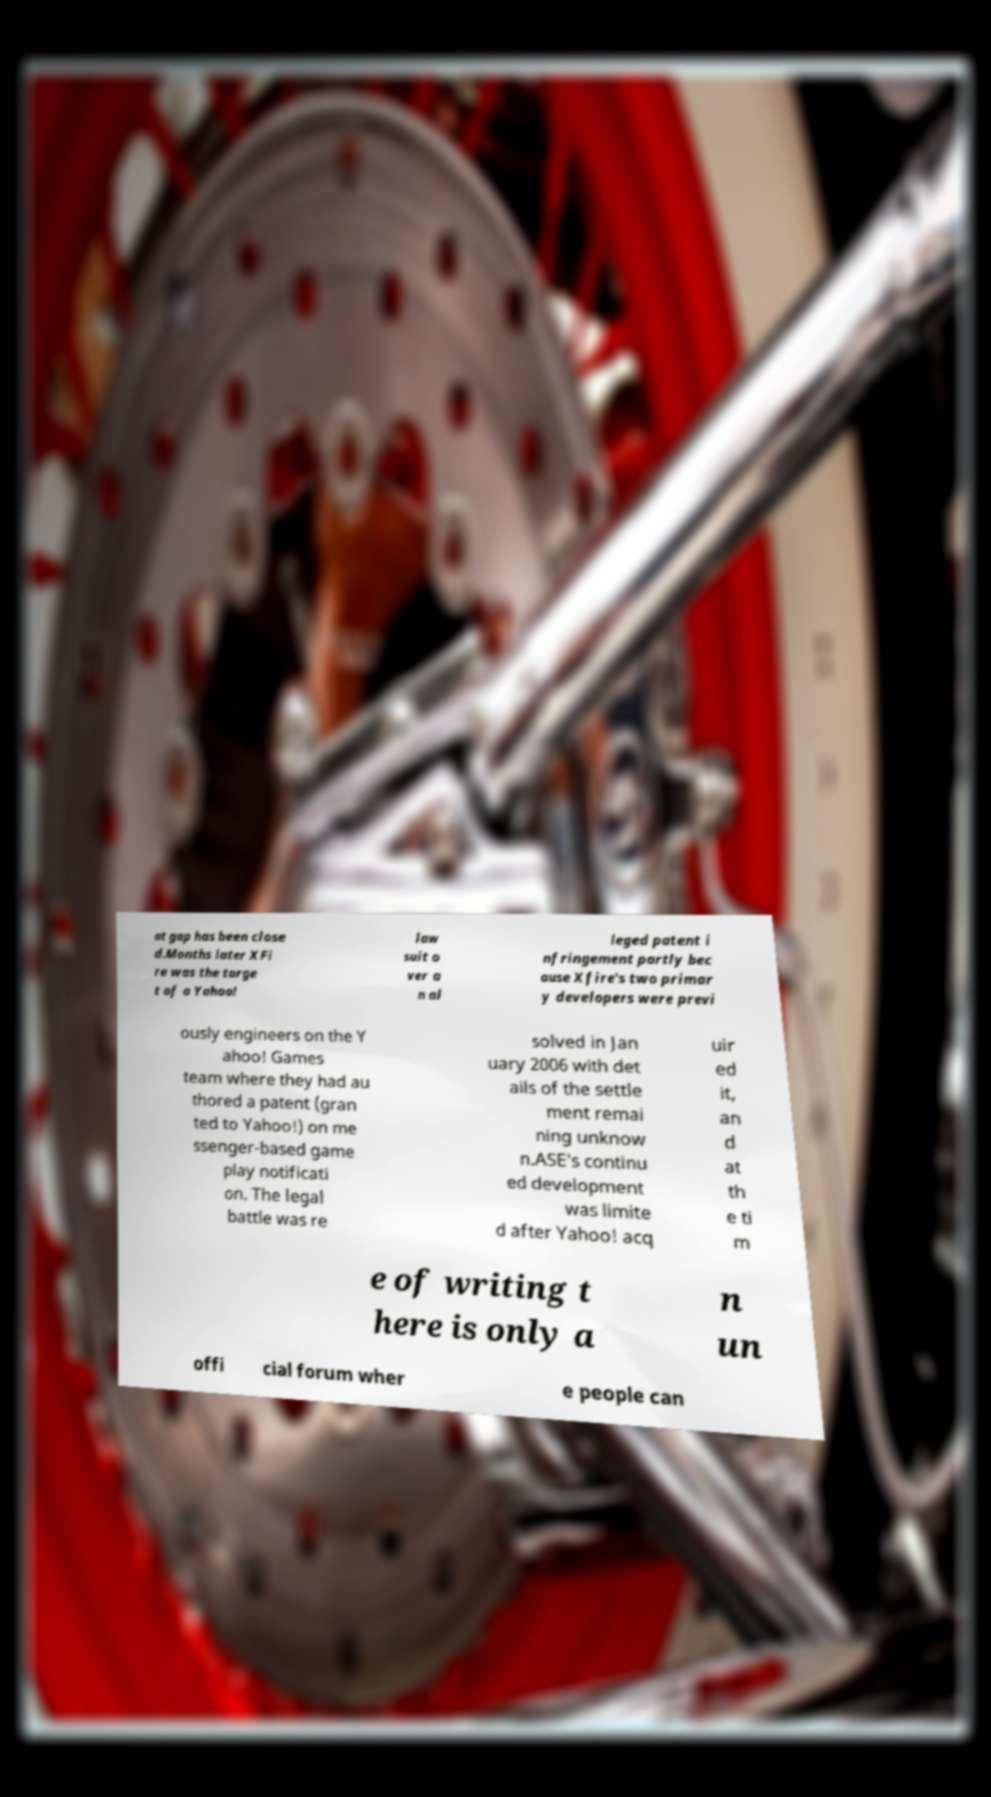Please identify and transcribe the text found in this image. at gap has been close d.Months later XFi re was the targe t of a Yahoo! law suit o ver a n al leged patent i nfringement partly bec ause Xfire's two primar y developers were previ ously engineers on the Y ahoo! Games team where they had au thored a patent (gran ted to Yahoo!) on me ssenger-based game play notificati on. The legal battle was re solved in Jan uary 2006 with det ails of the settle ment remai ning unknow n.ASE's continu ed development was limite d after Yahoo! acq uir ed it, an d at th e ti m e of writing t here is only a n un offi cial forum wher e people can 